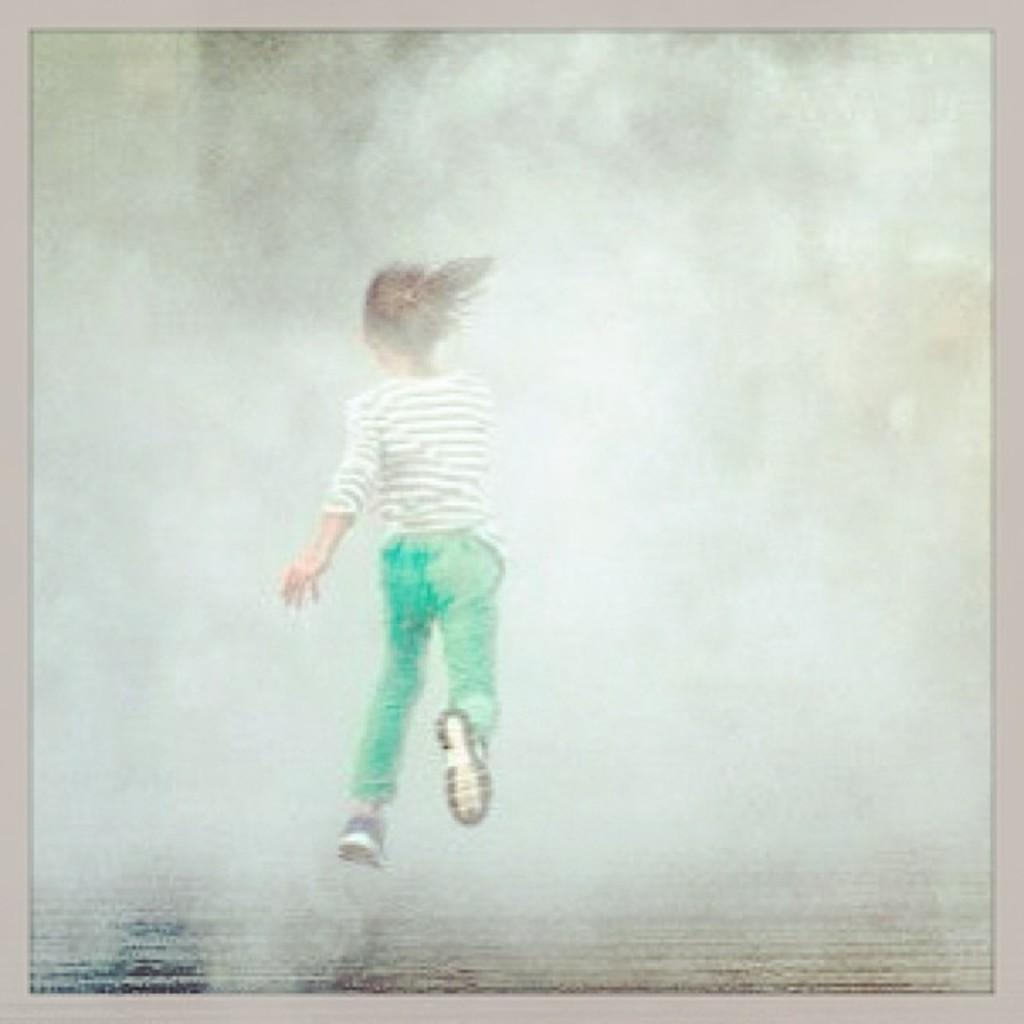How would you summarize this image in a sentence or two? This picture is photo. In the center of the image a girl is jumping. In the background the image is blur. 